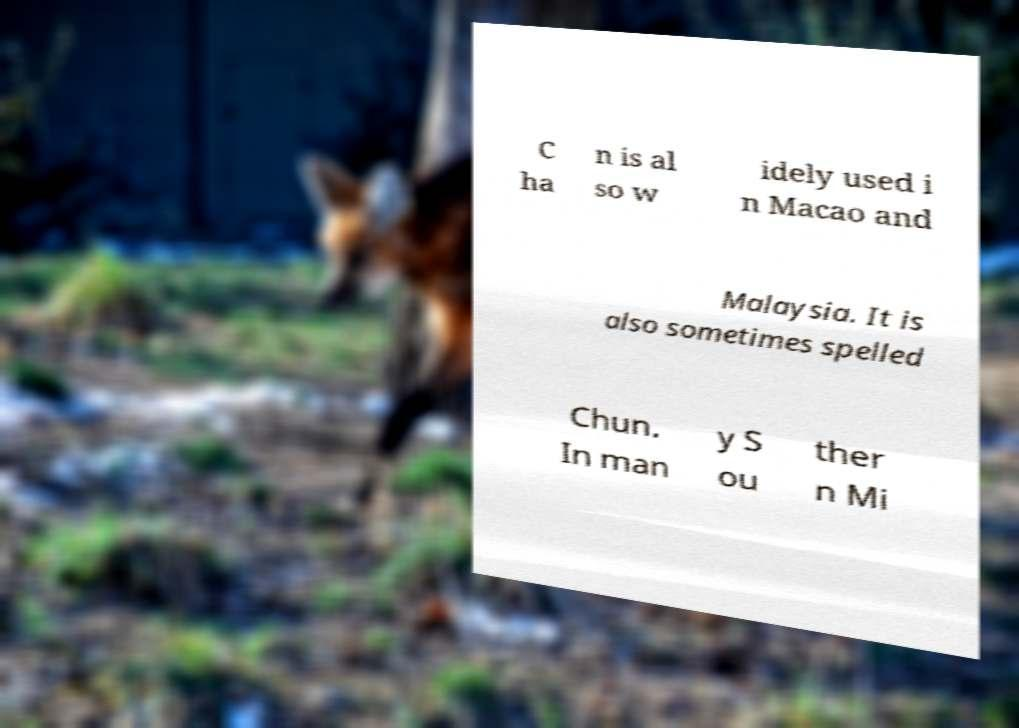Could you assist in decoding the text presented in this image and type it out clearly? C ha n is al so w idely used i n Macao and Malaysia. It is also sometimes spelled Chun. In man y S ou ther n Mi 